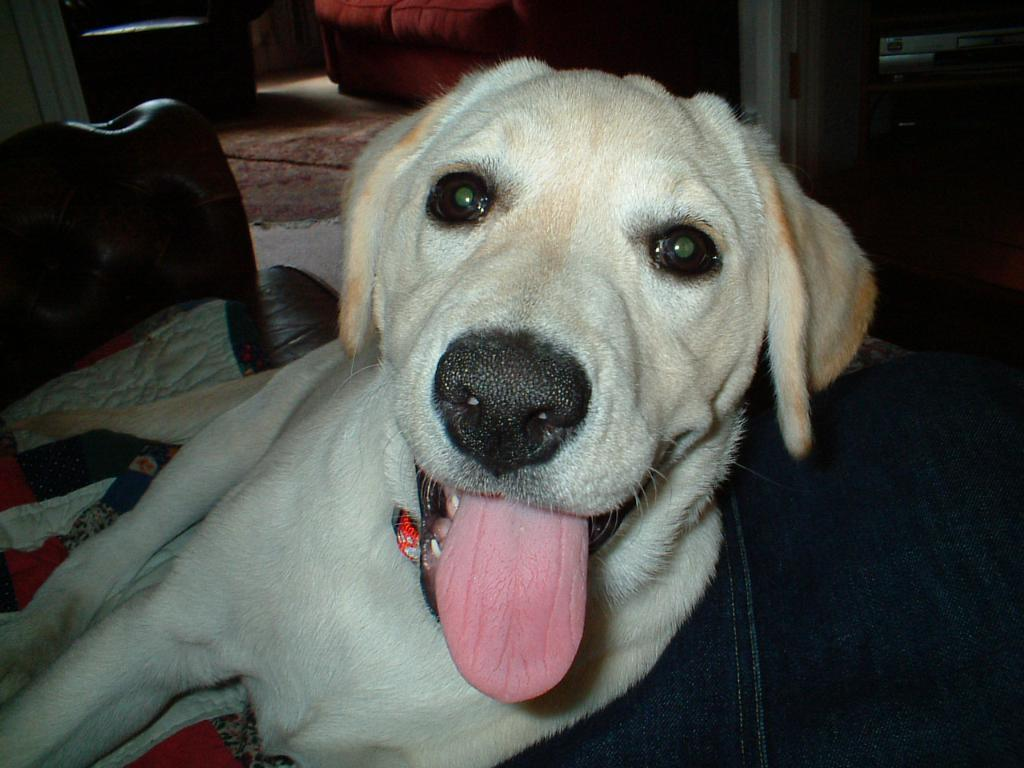What animal can be seen in the image? There is a dog in the image. What position is the dog in? The dog is lying on the floor. What can be seen in the background of the image? There is a wall, a couch, chairs, a door, and a floor mat in the background of the image. What type of truck can be seen driving on the edge of the land in the image? There is no truck or land present in the image; it features a dog lying on the floor with various background elements. 